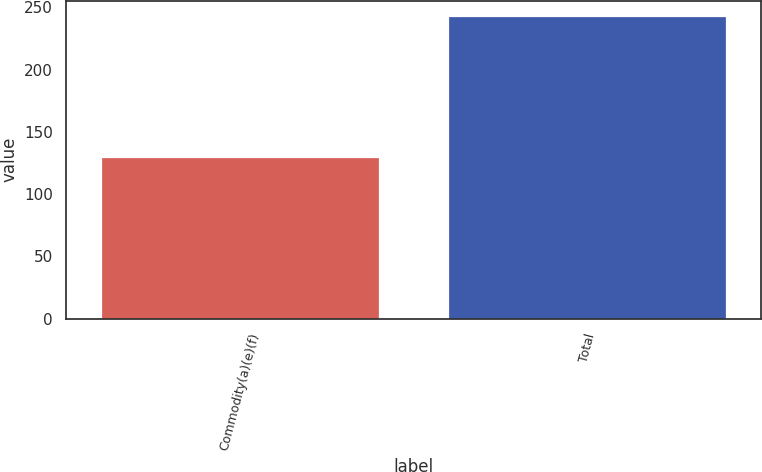<chart> <loc_0><loc_0><loc_500><loc_500><bar_chart><fcel>Commodity(a)(e)(f)<fcel>Total<nl><fcel>130<fcel>243<nl></chart> 